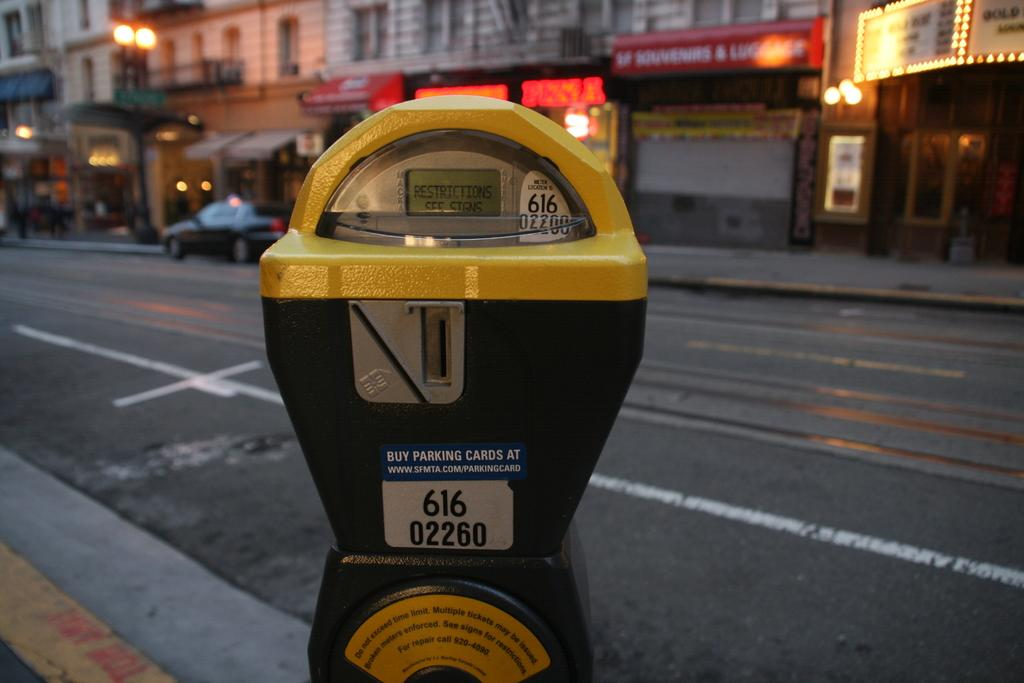<image>
Give a short and clear explanation of the subsequent image. A yellow and black parking meter with the number 616 02260 on the center. 